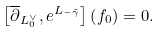<formula> <loc_0><loc_0><loc_500><loc_500>\left [ \overline { \partial } _ { L _ { 0 } ^ { \vee } } , e ^ { L _ { - \tilde { \gamma } } } \right ] \left ( f _ { 0 } \right ) = 0 .</formula> 